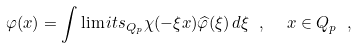Convert formula to latex. <formula><loc_0><loc_0><loc_500><loc_500>\varphi ( x ) = \int \lim i t s _ { Q _ { p } } \chi ( - \xi x ) \widehat { \varphi } ( \xi ) \, d \xi \ , \ \ x \in Q _ { p } \ ,</formula> 